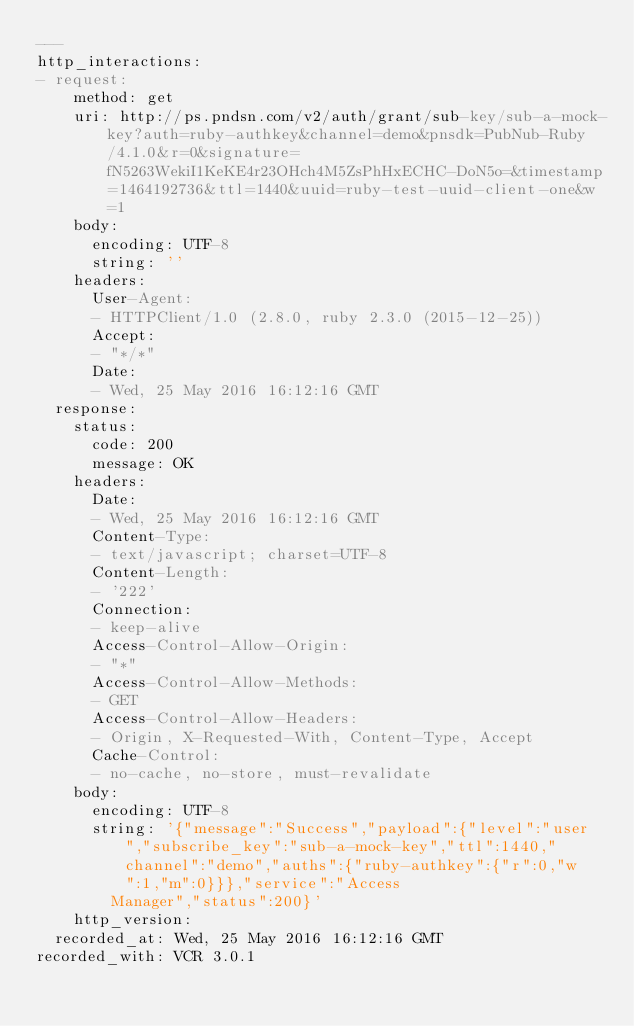Convert code to text. <code><loc_0><loc_0><loc_500><loc_500><_YAML_>---
http_interactions:
- request:
    method: get
    uri: http://ps.pndsn.com/v2/auth/grant/sub-key/sub-a-mock-key?auth=ruby-authkey&channel=demo&pnsdk=PubNub-Ruby/4.1.0&r=0&signature=fN5263WekiI1KeKE4r23OHch4M5ZsPhHxECHC-DoN5o=&timestamp=1464192736&ttl=1440&uuid=ruby-test-uuid-client-one&w=1
    body:
      encoding: UTF-8
      string: ''
    headers:
      User-Agent:
      - HTTPClient/1.0 (2.8.0, ruby 2.3.0 (2015-12-25))
      Accept:
      - "*/*"
      Date:
      - Wed, 25 May 2016 16:12:16 GMT
  response:
    status:
      code: 200
      message: OK
    headers:
      Date:
      - Wed, 25 May 2016 16:12:16 GMT
      Content-Type:
      - text/javascript; charset=UTF-8
      Content-Length:
      - '222'
      Connection:
      - keep-alive
      Access-Control-Allow-Origin:
      - "*"
      Access-Control-Allow-Methods:
      - GET
      Access-Control-Allow-Headers:
      - Origin, X-Requested-With, Content-Type, Accept
      Cache-Control:
      - no-cache, no-store, must-revalidate
    body:
      encoding: UTF-8
      string: '{"message":"Success","payload":{"level":"user","subscribe_key":"sub-a-mock-key","ttl":1440,"channel":"demo","auths":{"ruby-authkey":{"r":0,"w":1,"m":0}}},"service":"Access
        Manager","status":200}'
    http_version: 
  recorded_at: Wed, 25 May 2016 16:12:16 GMT
recorded_with: VCR 3.0.1
</code> 